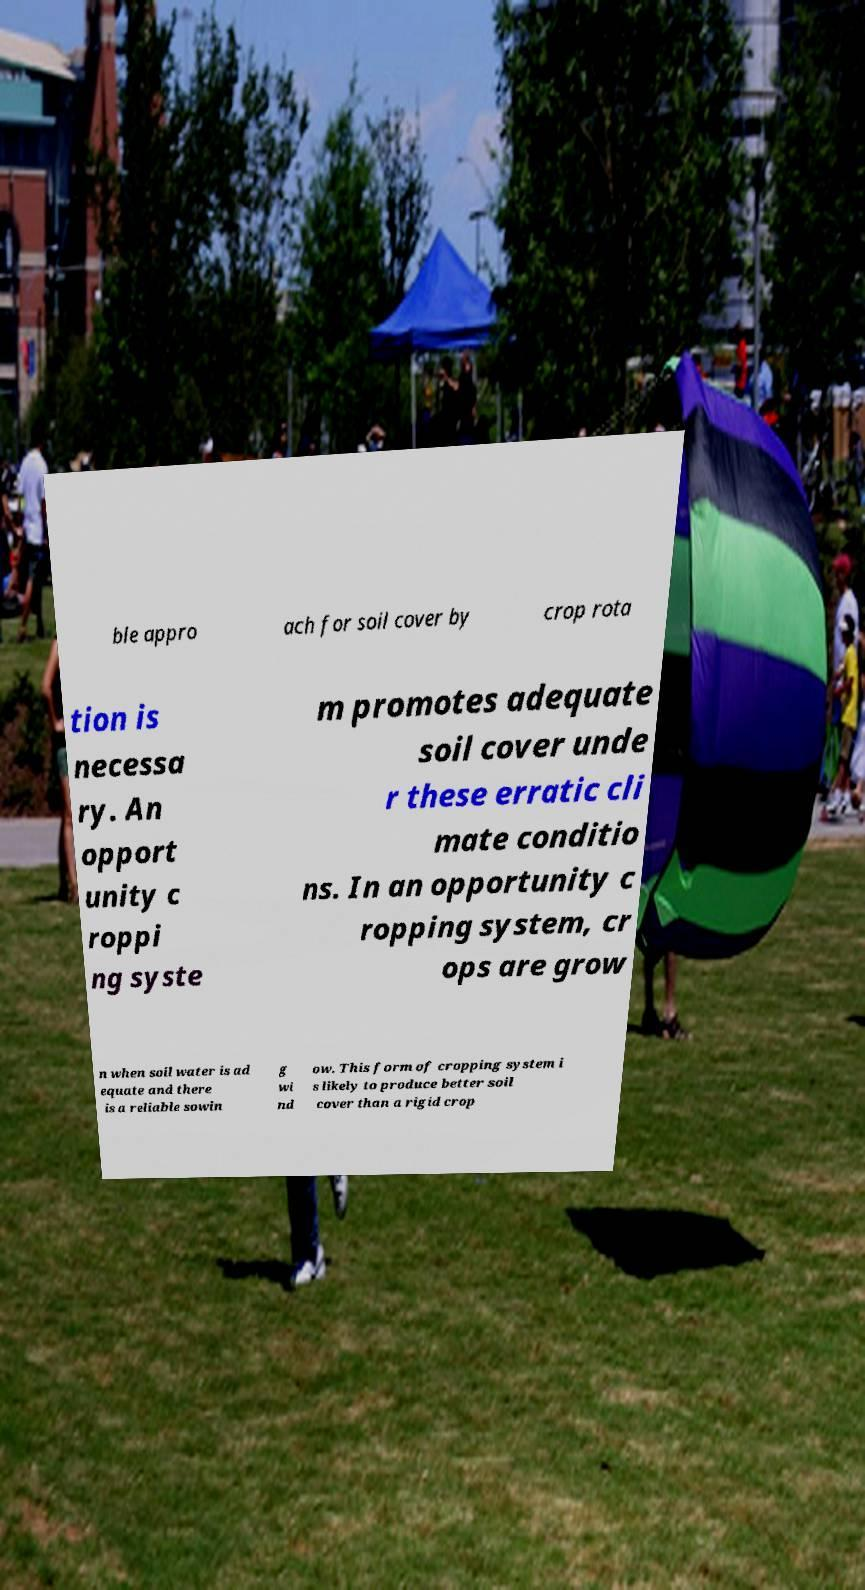I need the written content from this picture converted into text. Can you do that? ble appro ach for soil cover by crop rota tion is necessa ry. An opport unity c roppi ng syste m promotes adequate soil cover unde r these erratic cli mate conditio ns. In an opportunity c ropping system, cr ops are grow n when soil water is ad equate and there is a reliable sowin g wi nd ow. This form of cropping system i s likely to produce better soil cover than a rigid crop 